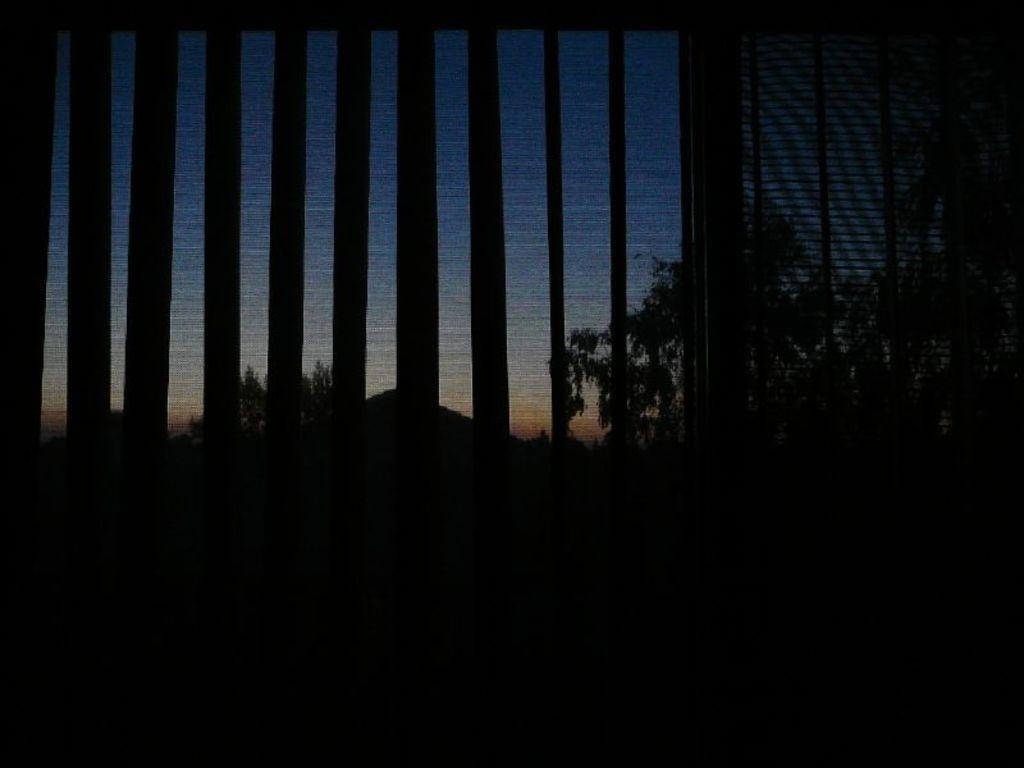What is the main object in the image? There is an object that looks like a grille in the image. What can be seen in the background of the image? There are trees and the sky visible in the background of the image. What is the profit made from the gold in the image? There is no mention of gold or profit in the image, so it is not possible to answer that question. 